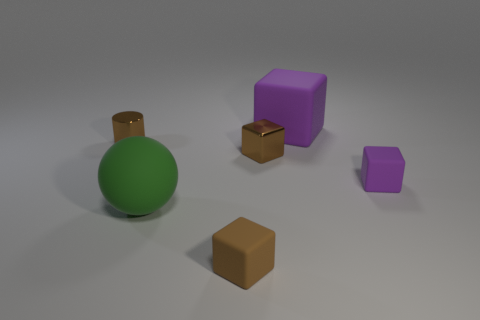Subtract all small metal blocks. How many blocks are left? 3 Subtract 2 blocks. How many blocks are left? 2 Add 2 small brown cubes. How many objects exist? 8 Subtract all cyan blocks. Subtract all blue balls. How many blocks are left? 4 Subtract all blocks. How many objects are left? 2 Add 5 purple cubes. How many purple cubes are left? 7 Add 3 purple objects. How many purple objects exist? 5 Subtract 1 green balls. How many objects are left? 5 Subtract all yellow cubes. Subtract all tiny purple rubber things. How many objects are left? 5 